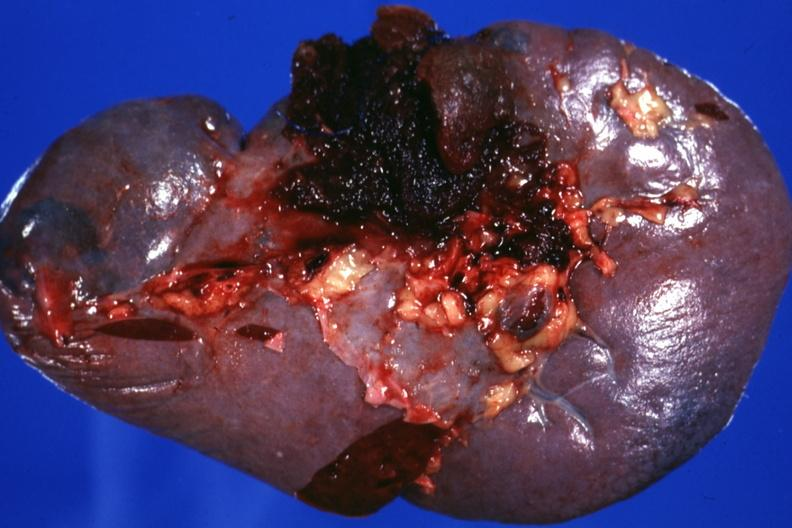does liver show close-up excellent example?
Answer the question using a single word or phrase. No 